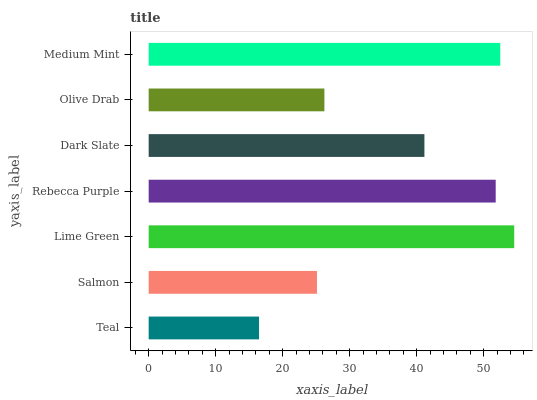Is Teal the minimum?
Answer yes or no. Yes. Is Lime Green the maximum?
Answer yes or no. Yes. Is Salmon the minimum?
Answer yes or no. No. Is Salmon the maximum?
Answer yes or no. No. Is Salmon greater than Teal?
Answer yes or no. Yes. Is Teal less than Salmon?
Answer yes or no. Yes. Is Teal greater than Salmon?
Answer yes or no. No. Is Salmon less than Teal?
Answer yes or no. No. Is Dark Slate the high median?
Answer yes or no. Yes. Is Dark Slate the low median?
Answer yes or no. Yes. Is Salmon the high median?
Answer yes or no. No. Is Olive Drab the low median?
Answer yes or no. No. 